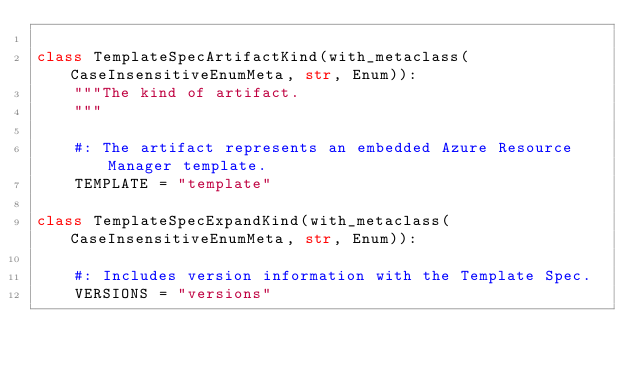<code> <loc_0><loc_0><loc_500><loc_500><_Python_>
class TemplateSpecArtifactKind(with_metaclass(CaseInsensitiveEnumMeta, str, Enum)):
    """The kind of artifact.
    """

    #: The artifact represents an embedded Azure Resource Manager template.
    TEMPLATE = "template"

class TemplateSpecExpandKind(with_metaclass(CaseInsensitiveEnumMeta, str, Enum)):

    #: Includes version information with the Template Spec.
    VERSIONS = "versions"
</code> 